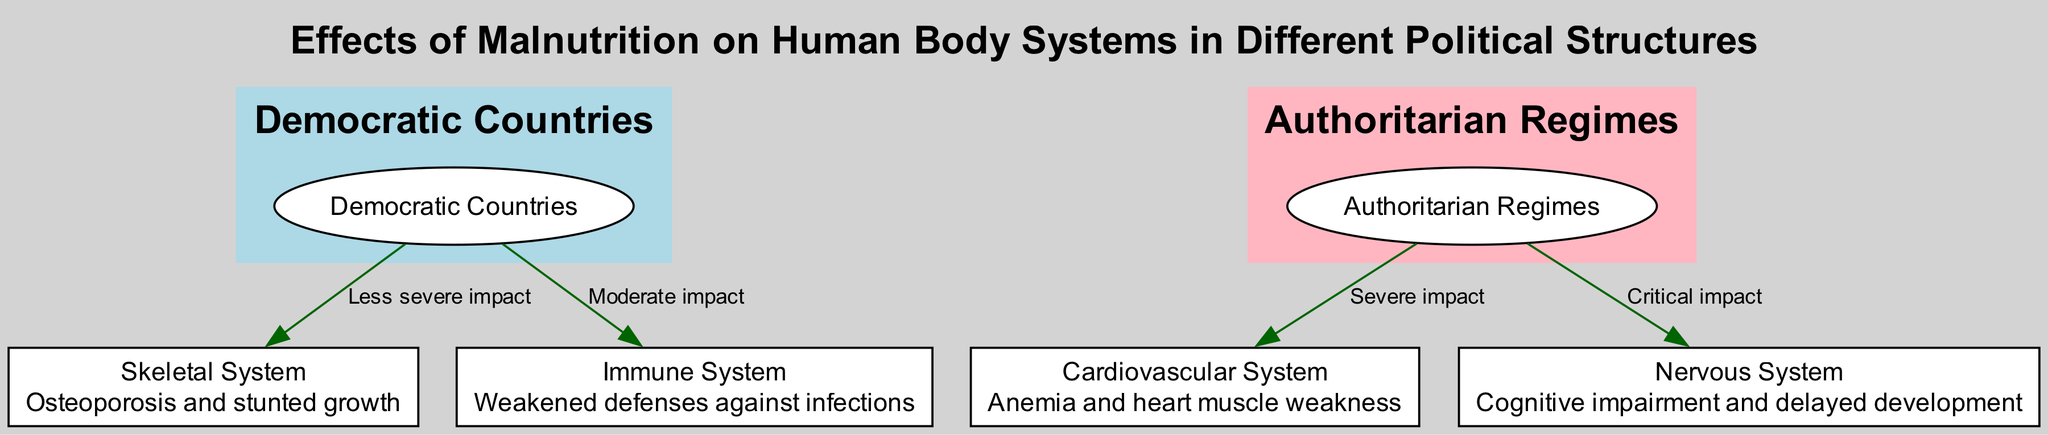What type of political structure generally has better food security? The diagram indicates that "Democratic Countries" are associated with better food security, as described in the node linked to this structure.
Answer: Democratic Countries Which body system is affected by malnutrition in authoritarian regimes? The diagram shows that both the "Cardiovascular System" and "Nervous System" are affected by malnutrition in authoritarian regimes, indicating these systems are connected to the respective node labeled "2".
Answer: Cardiovascular System, Nervous System What is the least severe impact of malnutrition indicated in the diagram? The edge labeled "Less severe impact" from the node "Democratic Countries" connects to the "Skeletal System," which indicates that this is the least severe impact shown in the diagram.
Answer: Skeletal System How many nodes are related to the impacts of malnutrition on the body? Counting all the nodes from "Skeletal System" to "Nervous System," there are a total of four nodes related to the impacts of malnutrition, aside from the two political structures.
Answer: 4 What type of impact does malnutrition have on the immune system in democratic countries? The edge labeled "Moderate impact" from "Democratic Countries" connects to the "Immune System," indicating the severity of impact in this political structure.
Answer: Moderate impact Which political structure is associated with the critical impact on the nervous system? According to the edge labeled "Critical impact," the "Nervous System" is connected to "Authoritarian Regimes," indicating this political structure is associated with a critical impact on the nervous system.
Answer: Authoritarian Regimes How does the diagram describe the skeletal system's health in democratic countries? The node for the "Skeletal System" describes effects like osteoporosis and stunted growth, while the connecting edge indicates a less severe impact when connected to "Democratic Countries."
Answer: Osteoporosis and stunted growth What color represents authoritarian regimes in the diagram? The subgraph representing "Authoritarian Regimes" is filled with pink color as seen in the color specification for that cluster, contrasting with the blue of democratic countries.
Answer: Light pink 